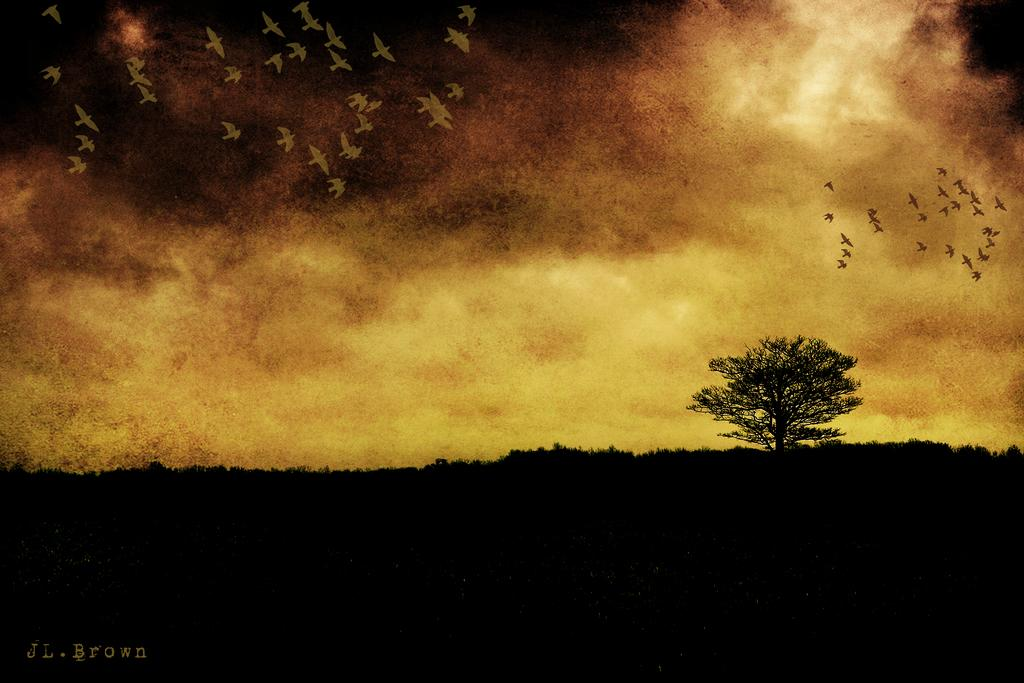What is the main subject of the image? There is a painting in the image. What is depicted in the painting? The painting features a tree, birds flying, and the sky in the background. Where is the text located in the painting? The text is in the left bottom corner of the painting. What type of calendar is hanging on the tree in the painting? There is no calendar present in the painting; it only features a tree, birds, and the sky. What type of cast can be seen on the bird's wing in the painting? There is no cast visible on any bird's wing in the painting; the birds are depicted as flying freely. 